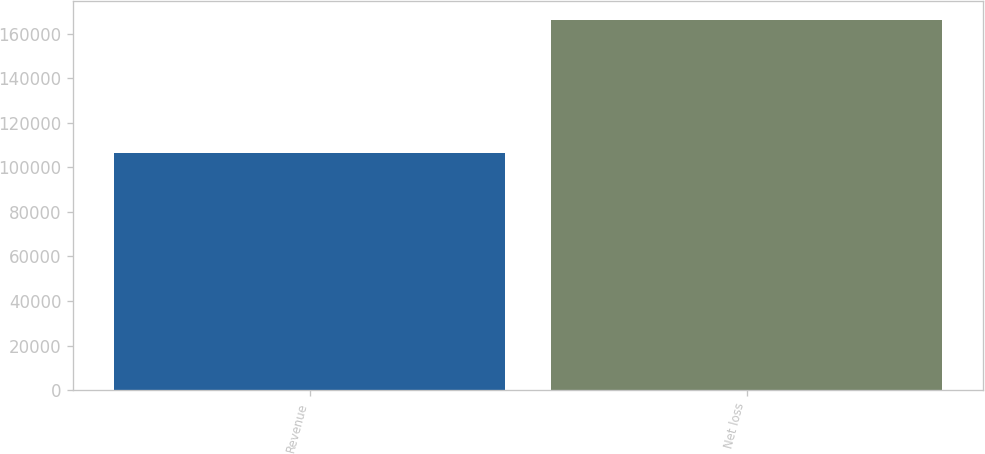<chart> <loc_0><loc_0><loc_500><loc_500><bar_chart><fcel>Revenue<fcel>Net loss<nl><fcel>106313<fcel>166317<nl></chart> 